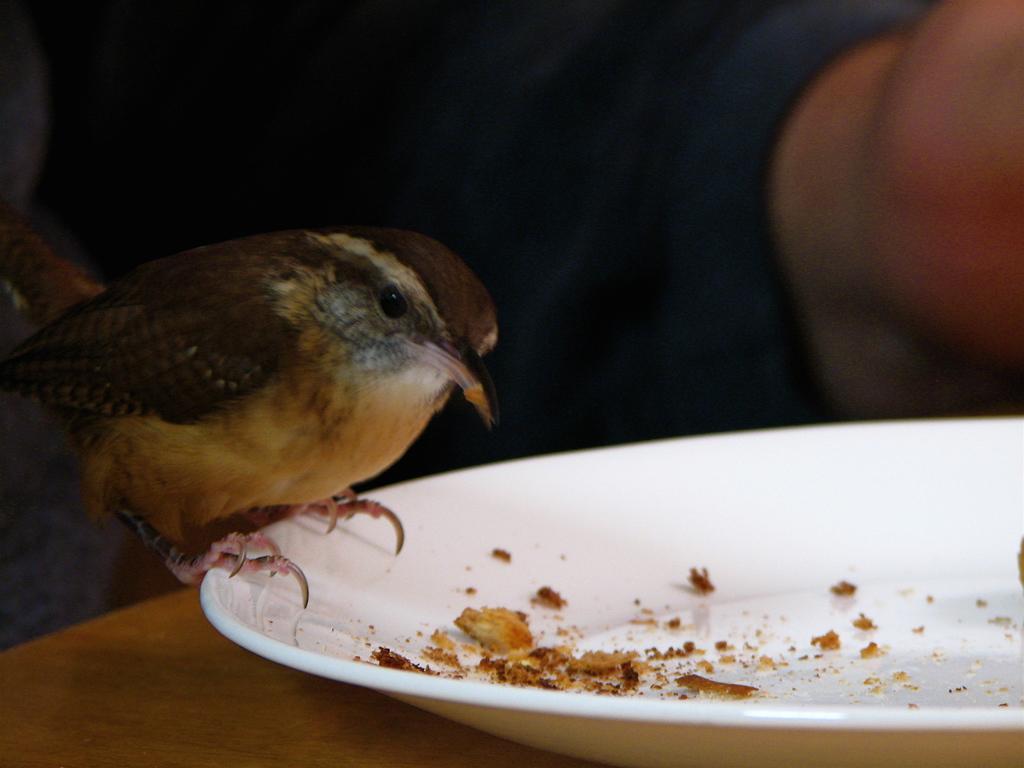Describe this image in one or two sentences. This picture shows a bird on the plate and we see some food in the plate on the table and we see a human. The bird is black and brown in color. 